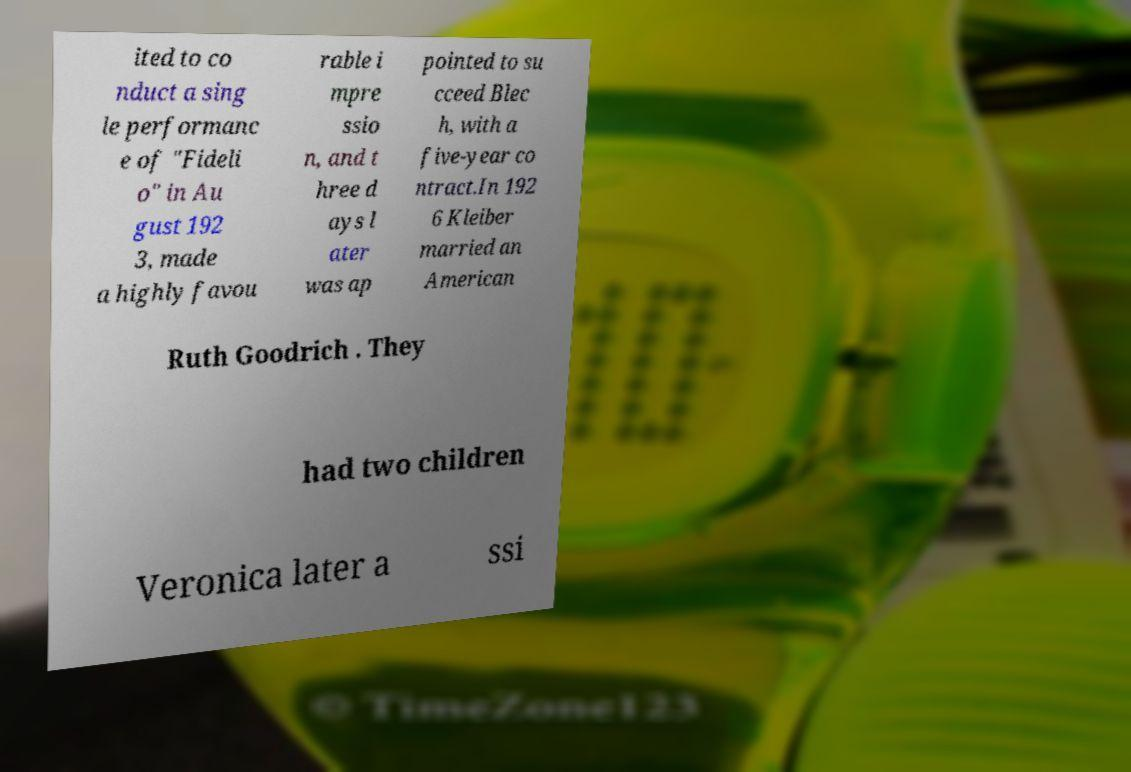Please identify and transcribe the text found in this image. ited to co nduct a sing le performanc e of "Fideli o" in Au gust 192 3, made a highly favou rable i mpre ssio n, and t hree d ays l ater was ap pointed to su cceed Blec h, with a five-year co ntract.In 192 6 Kleiber married an American Ruth Goodrich . They had two children Veronica later a ssi 